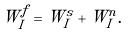<formula> <loc_0><loc_0><loc_500><loc_500>W _ { I } ^ { f } = W _ { I } ^ { s } + W _ { I } ^ { n } .</formula> 